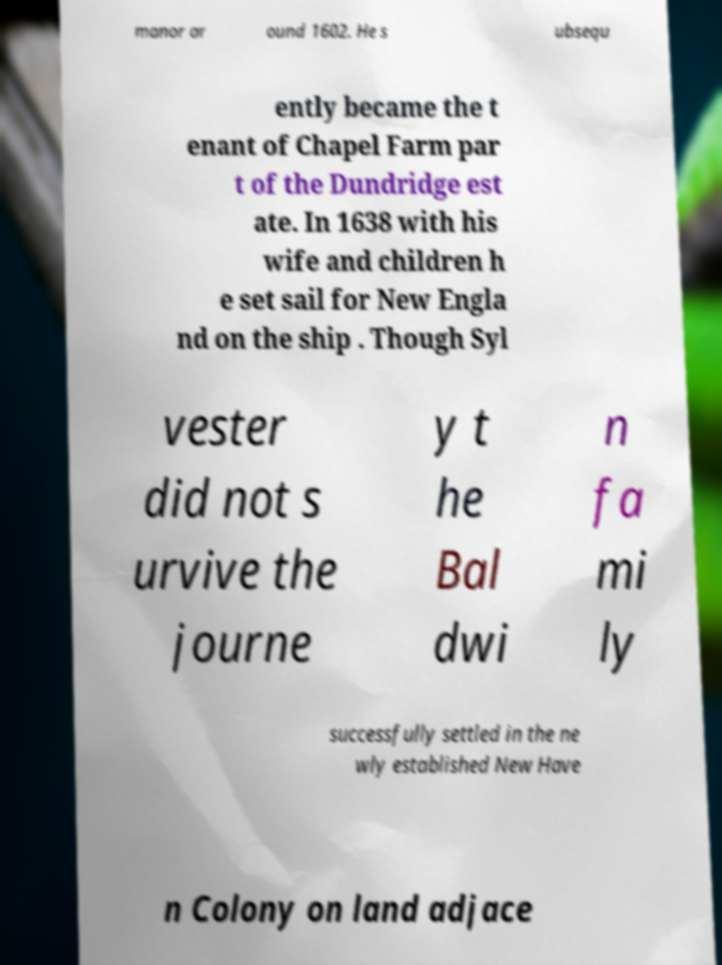What messages or text are displayed in this image? I need them in a readable, typed format. manor ar ound 1602. He s ubsequ ently became the t enant of Chapel Farm par t of the Dundridge est ate. In 1638 with his wife and children h e set sail for New Engla nd on the ship . Though Syl vester did not s urvive the journe y t he Bal dwi n fa mi ly successfully settled in the ne wly established New Have n Colony on land adjace 